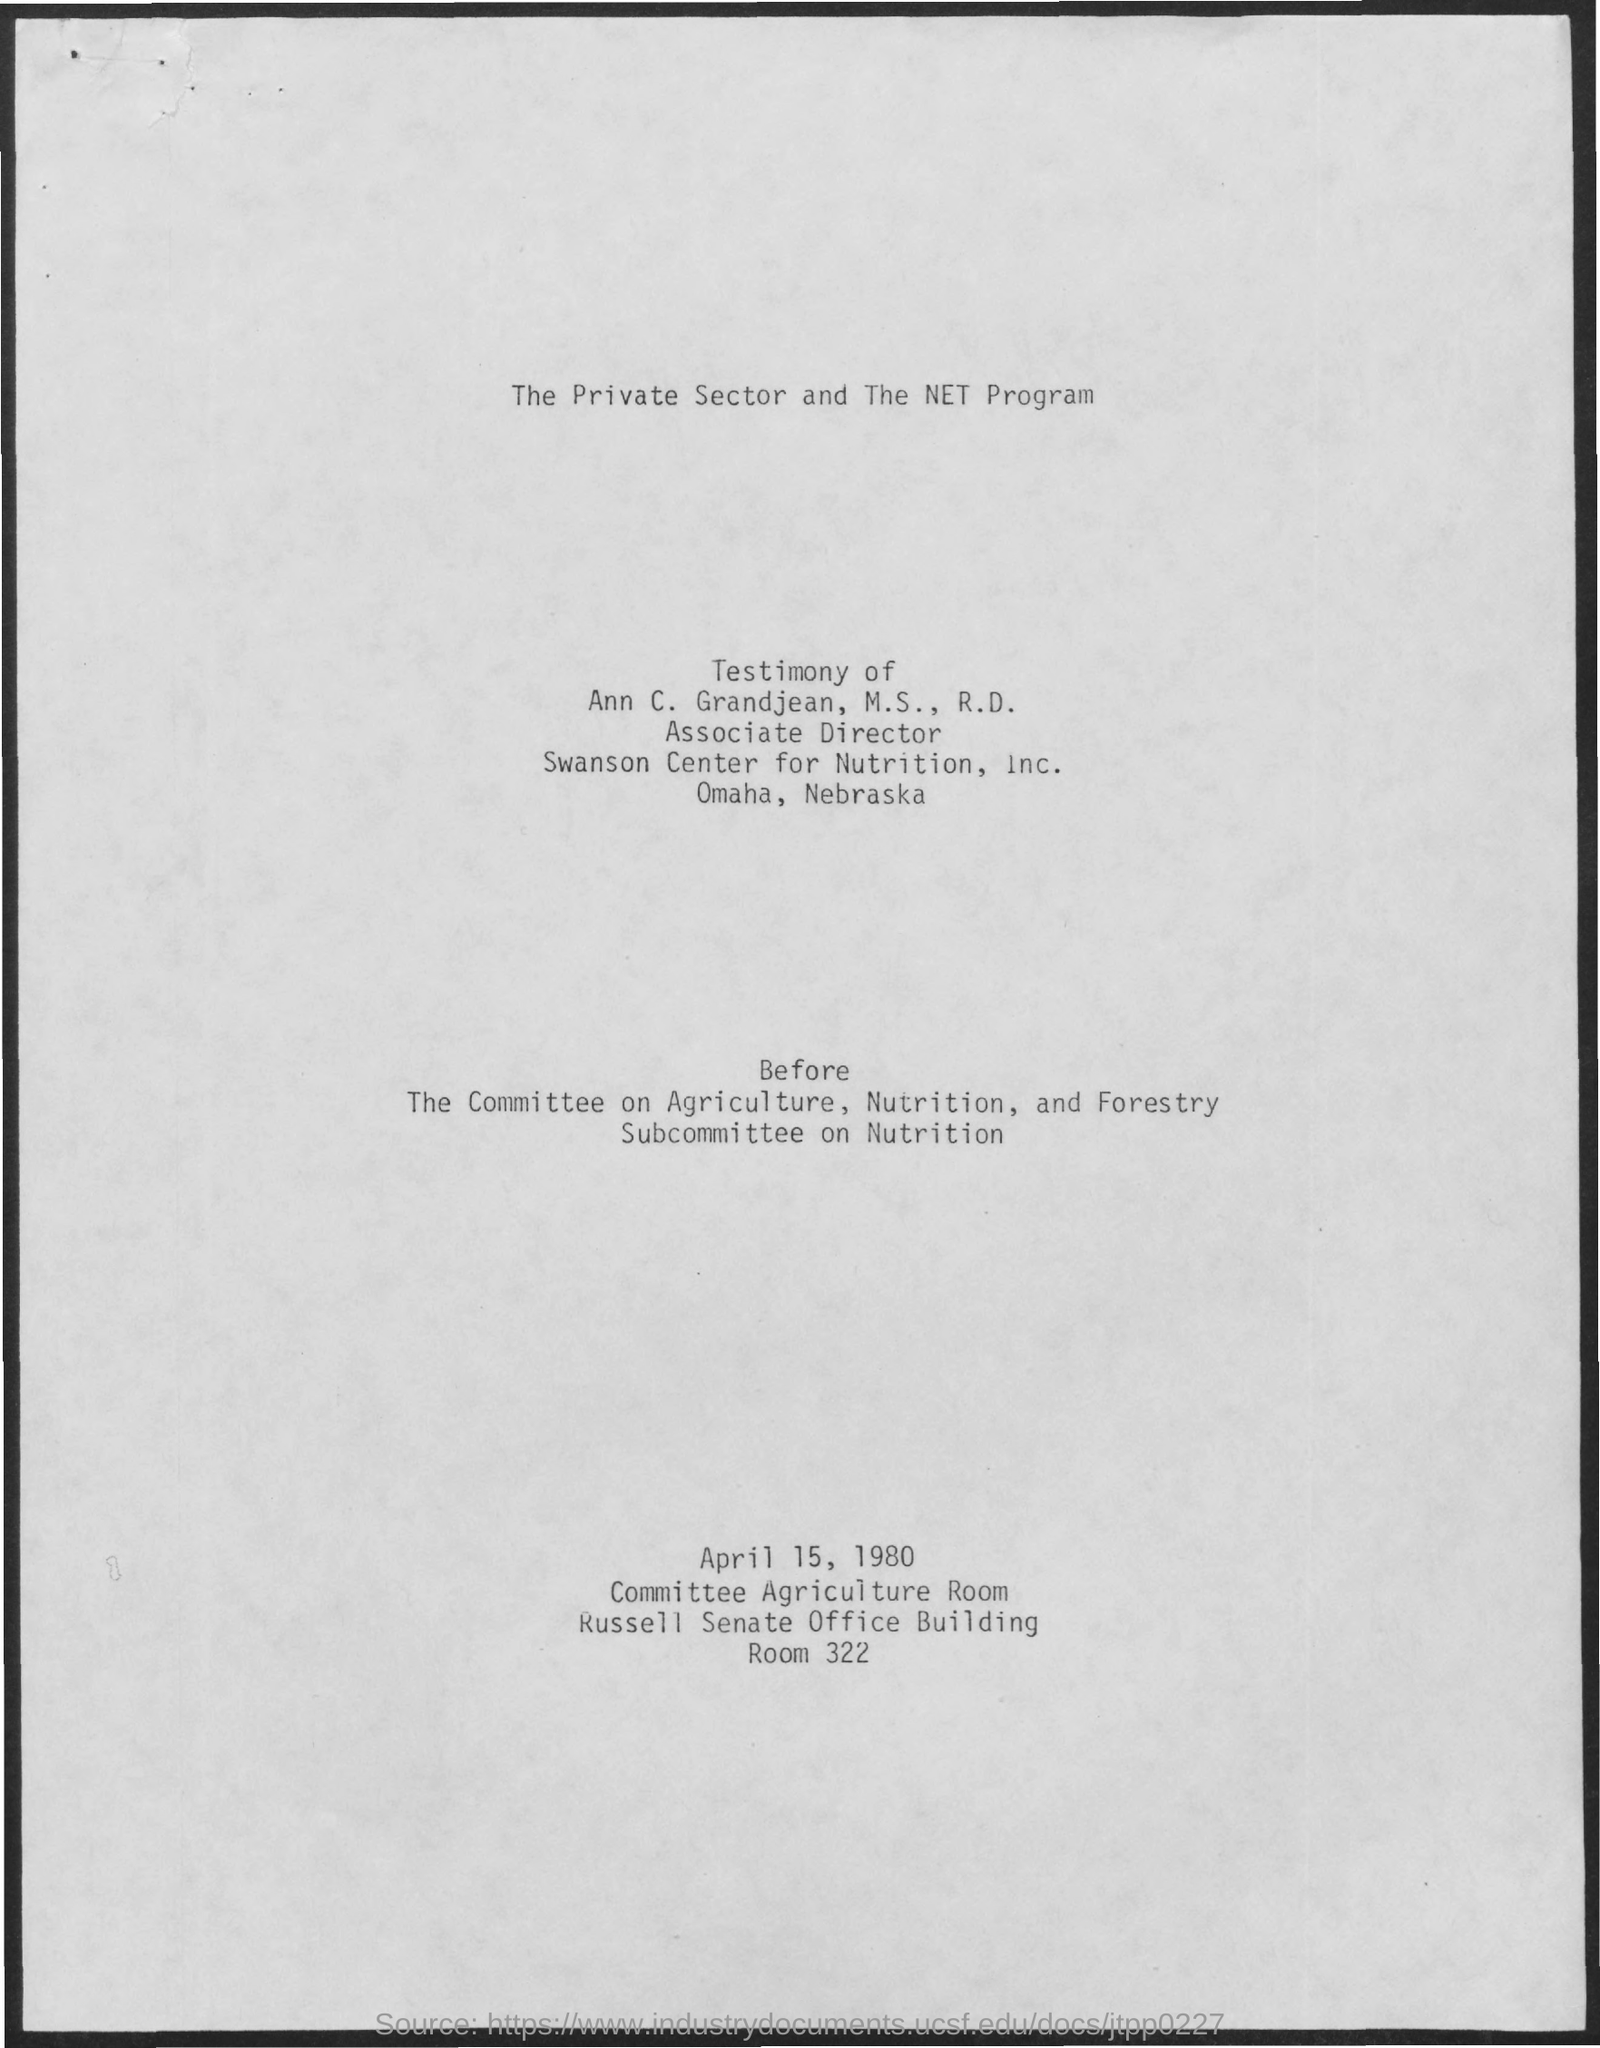Mention a couple of crucial points in this snapshot. Ann C. Grandjean holds the designation of Associate Director. Ann C. Grandjean, M.S., R.D., has provided the testimony that is being referred to. 